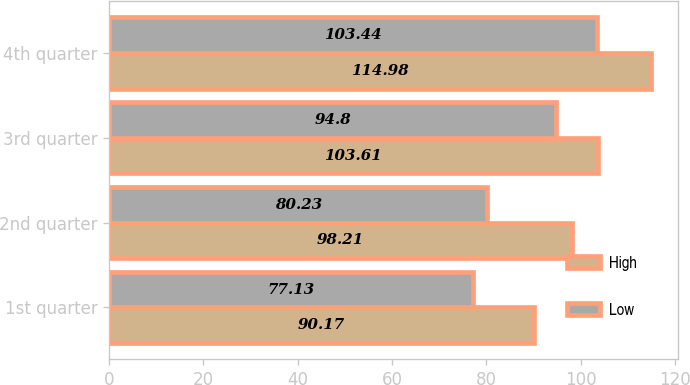Convert chart to OTSL. <chart><loc_0><loc_0><loc_500><loc_500><stacked_bar_chart><ecel><fcel>1st quarter<fcel>2nd quarter<fcel>3rd quarter<fcel>4th quarter<nl><fcel>High<fcel>90.17<fcel>98.21<fcel>103.61<fcel>114.98<nl><fcel>Low<fcel>77.13<fcel>80.23<fcel>94.8<fcel>103.44<nl></chart> 